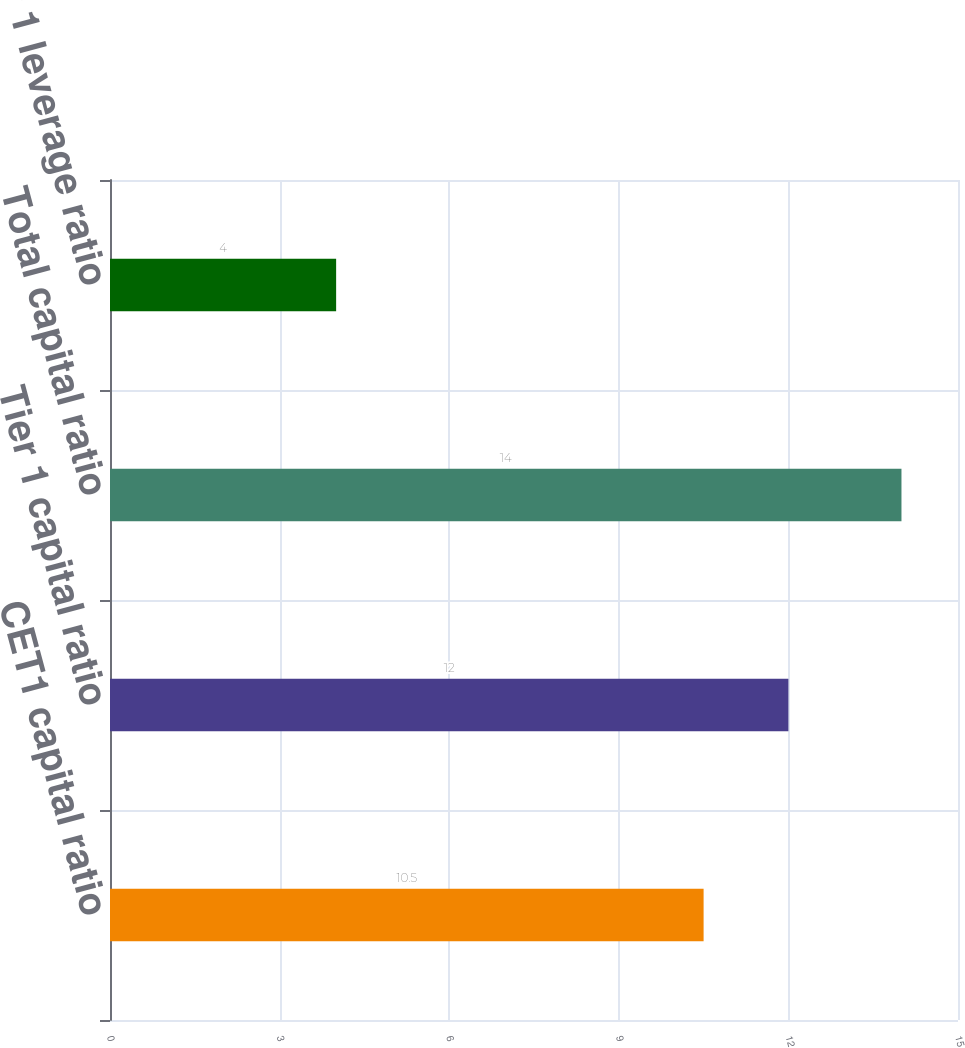Convert chart to OTSL. <chart><loc_0><loc_0><loc_500><loc_500><bar_chart><fcel>CET1 capital ratio<fcel>Tier 1 capital ratio<fcel>Total capital ratio<fcel>Tier 1 leverage ratio<nl><fcel>10.5<fcel>12<fcel>14<fcel>4<nl></chart> 